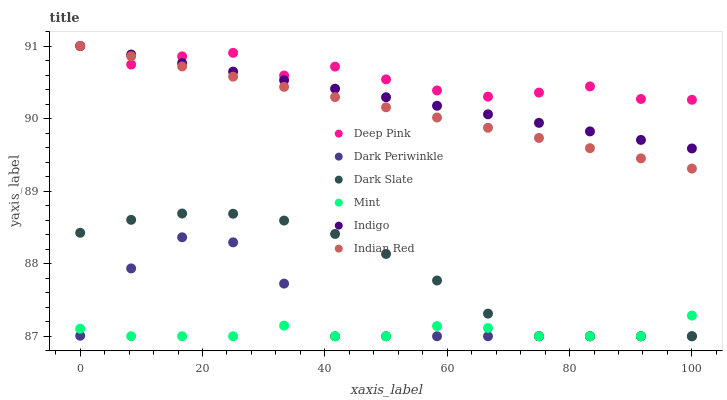Does Mint have the minimum area under the curve?
Answer yes or no. Yes. Does Deep Pink have the maximum area under the curve?
Answer yes or no. Yes. Does Indigo have the minimum area under the curve?
Answer yes or no. No. Does Indigo have the maximum area under the curve?
Answer yes or no. No. Is Indian Red the smoothest?
Answer yes or no. Yes. Is Dark Periwinkle the roughest?
Answer yes or no. Yes. Is Indigo the smoothest?
Answer yes or no. No. Is Indigo the roughest?
Answer yes or no. No. Does Dark Slate have the lowest value?
Answer yes or no. Yes. Does Indigo have the lowest value?
Answer yes or no. No. Does Indian Red have the highest value?
Answer yes or no. Yes. Does Dark Slate have the highest value?
Answer yes or no. No. Is Dark Periwinkle less than Indian Red?
Answer yes or no. Yes. Is Indian Red greater than Dark Periwinkle?
Answer yes or no. Yes. Does Indian Red intersect Deep Pink?
Answer yes or no. Yes. Is Indian Red less than Deep Pink?
Answer yes or no. No. Is Indian Red greater than Deep Pink?
Answer yes or no. No. Does Dark Periwinkle intersect Indian Red?
Answer yes or no. No. 